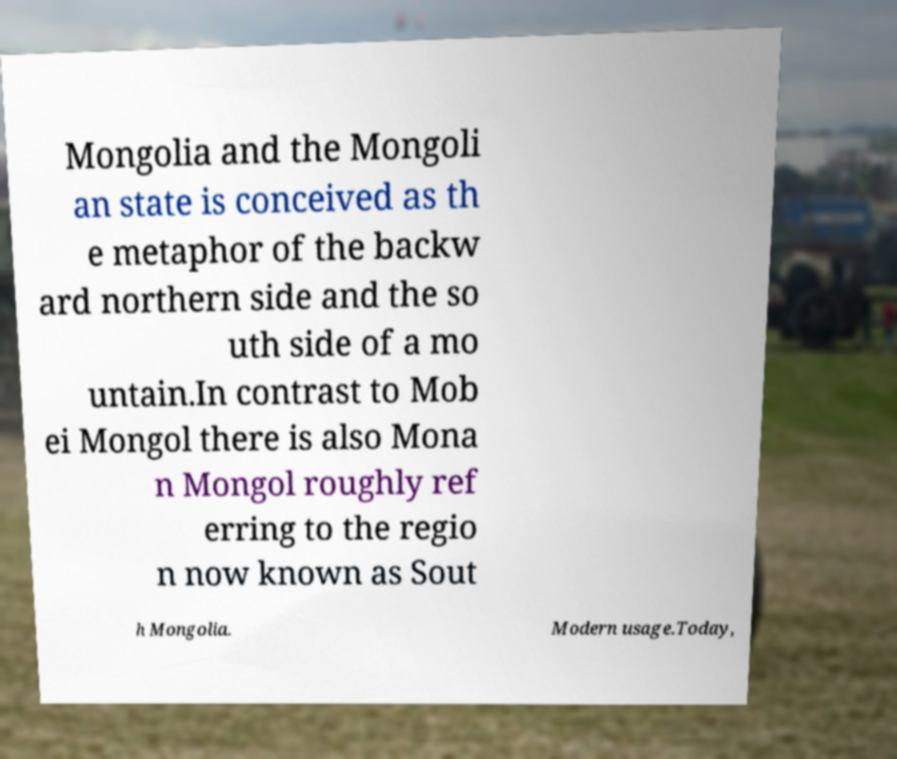I need the written content from this picture converted into text. Can you do that? Mongolia and the Mongoli an state is conceived as th e metaphor of the backw ard northern side and the so uth side of a mo untain.In contrast to Mob ei Mongol there is also Mona n Mongol roughly ref erring to the regio n now known as Sout h Mongolia. Modern usage.Today, 